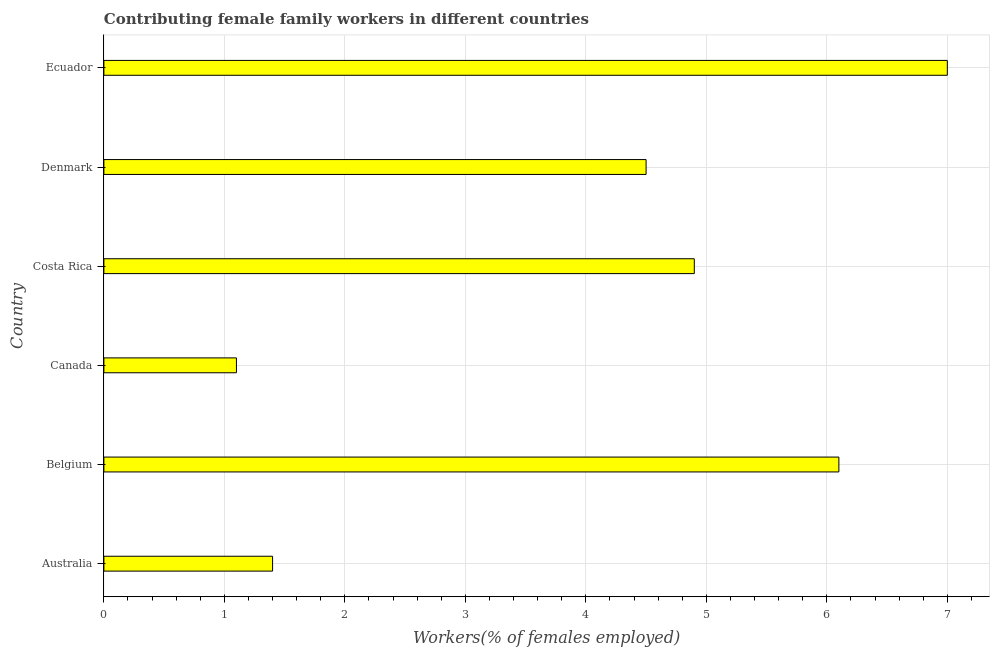Does the graph contain any zero values?
Provide a succinct answer. No. What is the title of the graph?
Your response must be concise. Contributing female family workers in different countries. What is the label or title of the X-axis?
Offer a terse response. Workers(% of females employed). What is the label or title of the Y-axis?
Provide a succinct answer. Country. Across all countries, what is the minimum contributing female family workers?
Ensure brevity in your answer.  1.1. In which country was the contributing female family workers maximum?
Offer a terse response. Ecuador. In which country was the contributing female family workers minimum?
Provide a succinct answer. Canada. What is the sum of the contributing female family workers?
Make the answer very short. 25. What is the difference between the contributing female family workers in Belgium and Canada?
Offer a very short reply. 5. What is the average contributing female family workers per country?
Provide a succinct answer. 4.17. What is the median contributing female family workers?
Make the answer very short. 4.7. In how many countries, is the contributing female family workers greater than 0.4 %?
Provide a short and direct response. 6. What is the ratio of the contributing female family workers in Denmark to that in Ecuador?
Provide a short and direct response. 0.64. Is the difference between the contributing female family workers in Denmark and Ecuador greater than the difference between any two countries?
Provide a succinct answer. No. What is the difference between the highest and the second highest contributing female family workers?
Ensure brevity in your answer.  0.9. Is the sum of the contributing female family workers in Costa Rica and Ecuador greater than the maximum contributing female family workers across all countries?
Your response must be concise. Yes. How many countries are there in the graph?
Ensure brevity in your answer.  6. What is the difference between two consecutive major ticks on the X-axis?
Keep it short and to the point. 1. Are the values on the major ticks of X-axis written in scientific E-notation?
Provide a succinct answer. No. What is the Workers(% of females employed) of Australia?
Keep it short and to the point. 1.4. What is the Workers(% of females employed) of Belgium?
Offer a very short reply. 6.1. What is the Workers(% of females employed) in Canada?
Keep it short and to the point. 1.1. What is the Workers(% of females employed) in Costa Rica?
Give a very brief answer. 4.9. What is the Workers(% of females employed) of Denmark?
Your answer should be very brief. 4.5. What is the Workers(% of females employed) of Ecuador?
Keep it short and to the point. 7. What is the difference between the Workers(% of females employed) in Australia and Belgium?
Keep it short and to the point. -4.7. What is the difference between the Workers(% of females employed) in Australia and Costa Rica?
Offer a terse response. -3.5. What is the difference between the Workers(% of females employed) in Australia and Ecuador?
Your response must be concise. -5.6. What is the difference between the Workers(% of females employed) in Belgium and Canada?
Your answer should be very brief. 5. What is the difference between the Workers(% of females employed) in Belgium and Ecuador?
Your answer should be compact. -0.9. What is the difference between the Workers(% of females employed) in Canada and Costa Rica?
Your response must be concise. -3.8. What is the difference between the Workers(% of females employed) in Canada and Denmark?
Give a very brief answer. -3.4. What is the difference between the Workers(% of females employed) in Canada and Ecuador?
Your answer should be very brief. -5.9. What is the ratio of the Workers(% of females employed) in Australia to that in Belgium?
Provide a succinct answer. 0.23. What is the ratio of the Workers(% of females employed) in Australia to that in Canada?
Your answer should be very brief. 1.27. What is the ratio of the Workers(% of females employed) in Australia to that in Costa Rica?
Make the answer very short. 0.29. What is the ratio of the Workers(% of females employed) in Australia to that in Denmark?
Offer a terse response. 0.31. What is the ratio of the Workers(% of females employed) in Australia to that in Ecuador?
Your answer should be compact. 0.2. What is the ratio of the Workers(% of females employed) in Belgium to that in Canada?
Your answer should be compact. 5.54. What is the ratio of the Workers(% of females employed) in Belgium to that in Costa Rica?
Provide a succinct answer. 1.25. What is the ratio of the Workers(% of females employed) in Belgium to that in Denmark?
Make the answer very short. 1.36. What is the ratio of the Workers(% of females employed) in Belgium to that in Ecuador?
Provide a short and direct response. 0.87. What is the ratio of the Workers(% of females employed) in Canada to that in Costa Rica?
Ensure brevity in your answer.  0.22. What is the ratio of the Workers(% of females employed) in Canada to that in Denmark?
Your answer should be very brief. 0.24. What is the ratio of the Workers(% of females employed) in Canada to that in Ecuador?
Offer a terse response. 0.16. What is the ratio of the Workers(% of females employed) in Costa Rica to that in Denmark?
Your answer should be very brief. 1.09. What is the ratio of the Workers(% of females employed) in Denmark to that in Ecuador?
Make the answer very short. 0.64. 